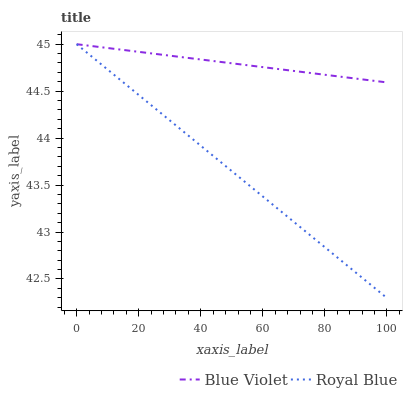Does Blue Violet have the minimum area under the curve?
Answer yes or no. No. Is Blue Violet the roughest?
Answer yes or no. No. Does Blue Violet have the lowest value?
Answer yes or no. No. 